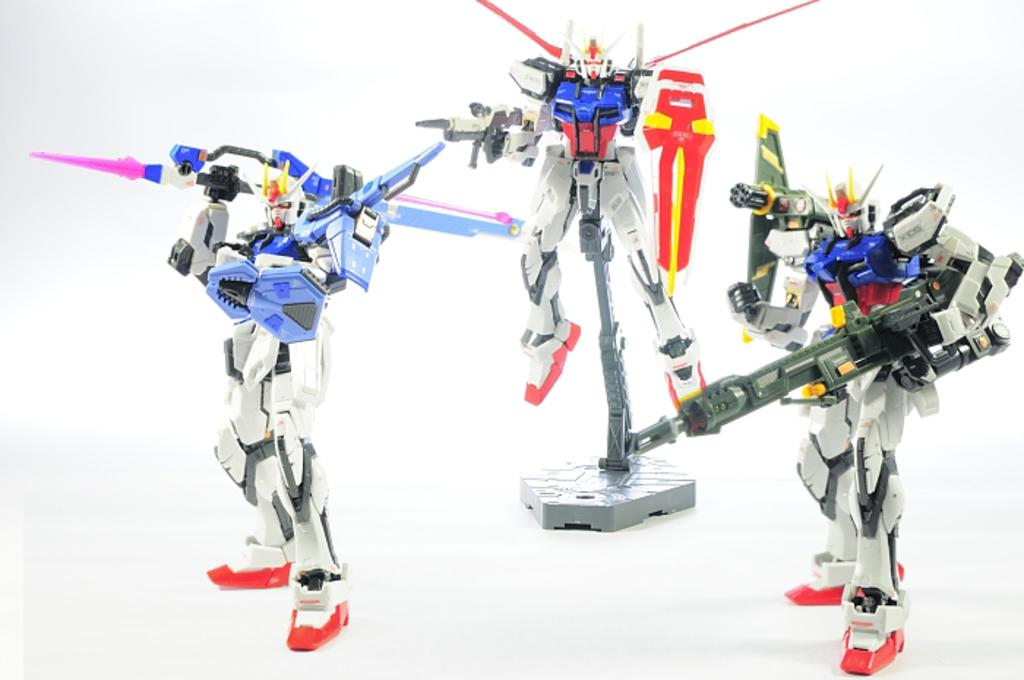How many robots are present in the image? There are three robots in the image. What type of lamp is on the head of one of the robots in the image? There are no lamps present on the robots in the image; they are robots, not lamps. 